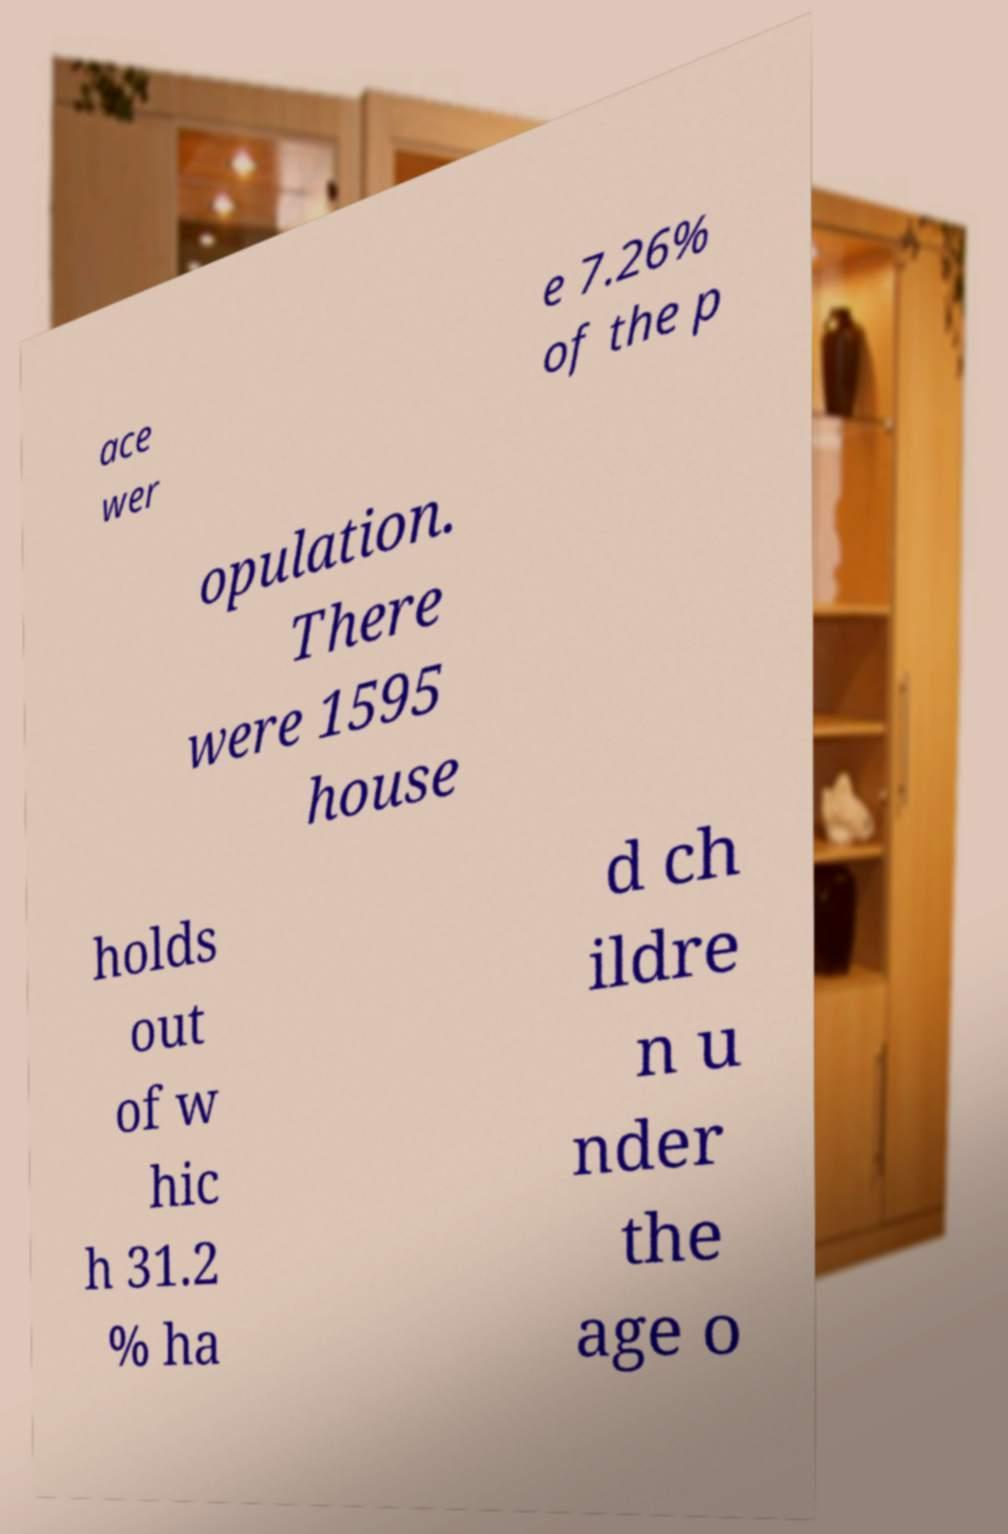Please identify and transcribe the text found in this image. ace wer e 7.26% of the p opulation. There were 1595 house holds out of w hic h 31.2 % ha d ch ildre n u nder the age o 